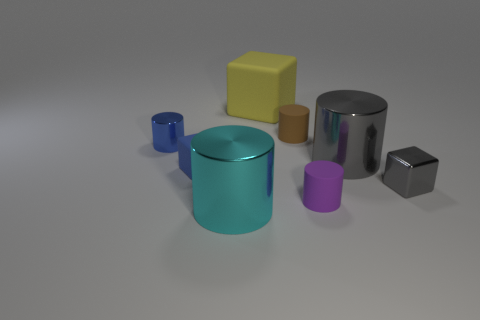Is there anything else that has the same color as the metallic cube?
Your answer should be compact. Yes. There is a small metallic object in front of the blue metallic object; is its color the same as the large metal thing behind the blue cube?
Offer a very short reply. Yes. What is the color of the large object behind the tiny blue metallic cylinder?
Provide a succinct answer. Yellow. There is a cylinder that is to the left of the cyan cylinder; does it have the same size as the purple thing?
Offer a terse response. Yes. Are there fewer large yellow things than tiny balls?
Offer a terse response. No. The large shiny object that is the same color as the small metal cube is what shape?
Your answer should be very brief. Cylinder. What number of matte cylinders are in front of the blue cube?
Keep it short and to the point. 1. Is the shape of the tiny gray shiny thing the same as the small blue matte object?
Provide a short and direct response. Yes. How many small things are behind the purple rubber cylinder and on the right side of the tiny brown object?
Ensure brevity in your answer.  1. How many objects are purple things or big cylinders that are right of the big matte cube?
Make the answer very short. 2. 